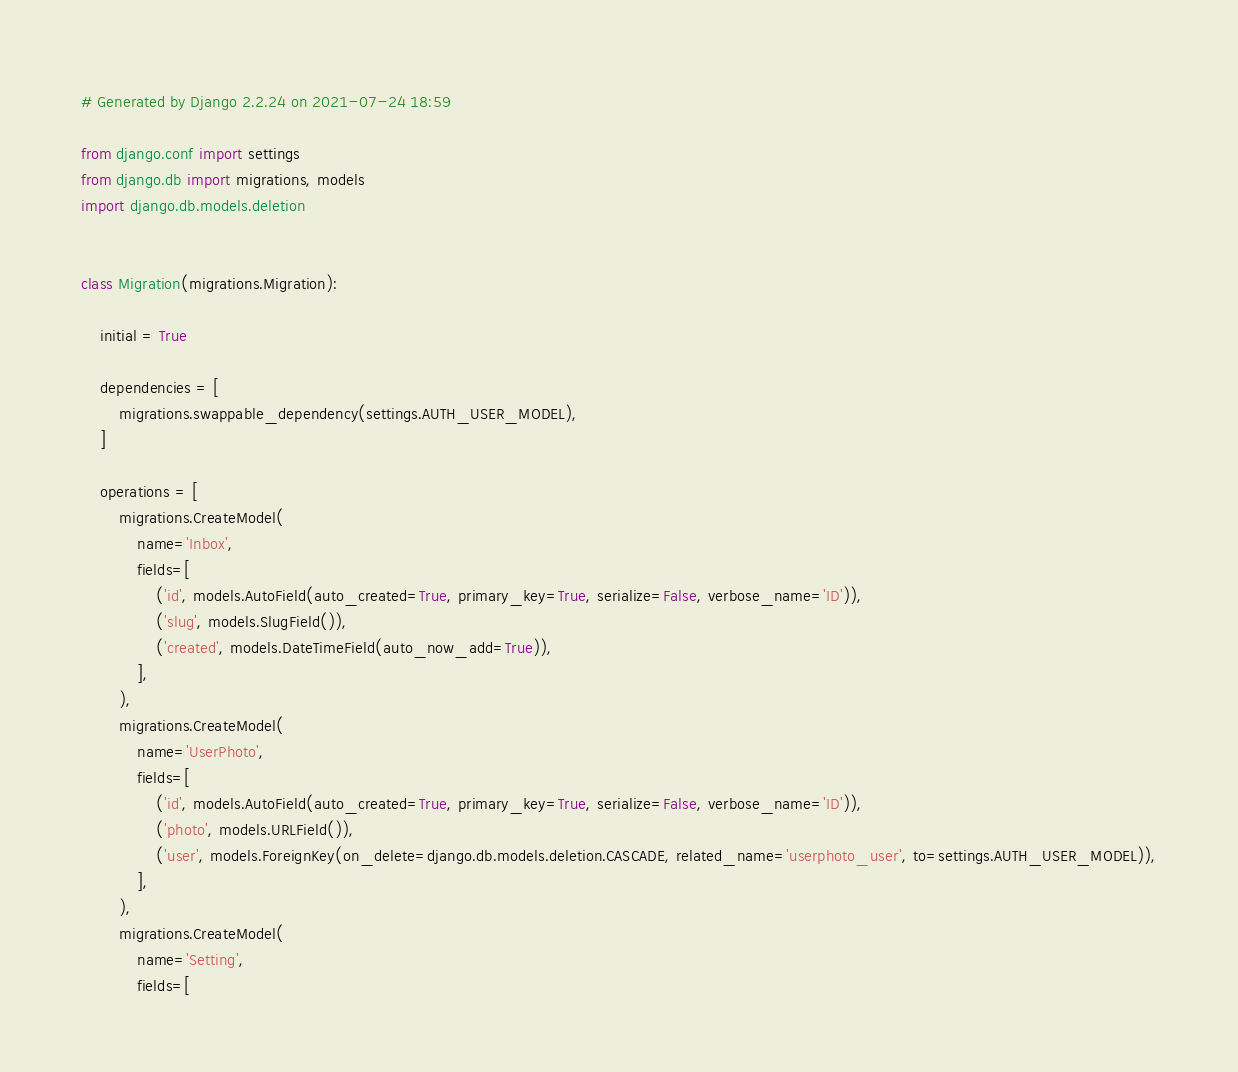Convert code to text. <code><loc_0><loc_0><loc_500><loc_500><_Python_># Generated by Django 2.2.24 on 2021-07-24 18:59

from django.conf import settings
from django.db import migrations, models
import django.db.models.deletion


class Migration(migrations.Migration):

    initial = True

    dependencies = [
        migrations.swappable_dependency(settings.AUTH_USER_MODEL),
    ]

    operations = [
        migrations.CreateModel(
            name='Inbox',
            fields=[
                ('id', models.AutoField(auto_created=True, primary_key=True, serialize=False, verbose_name='ID')),
                ('slug', models.SlugField()),
                ('created', models.DateTimeField(auto_now_add=True)),
            ],
        ),
        migrations.CreateModel(
            name='UserPhoto',
            fields=[
                ('id', models.AutoField(auto_created=True, primary_key=True, serialize=False, verbose_name='ID')),
                ('photo', models.URLField()),
                ('user', models.ForeignKey(on_delete=django.db.models.deletion.CASCADE, related_name='userphoto_user', to=settings.AUTH_USER_MODEL)),
            ],
        ),
        migrations.CreateModel(
            name='Setting',
            fields=[</code> 